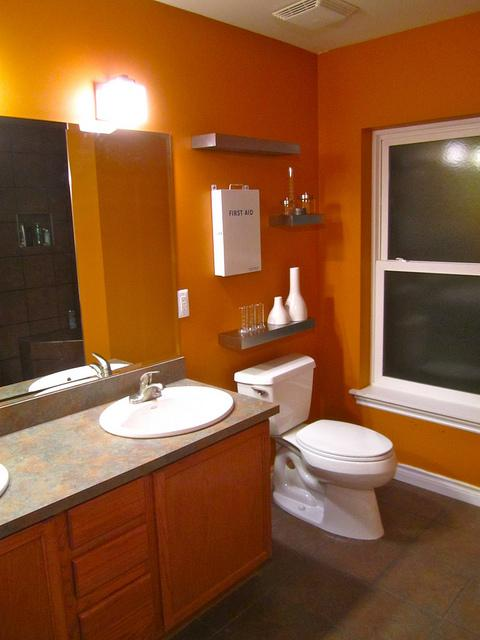What color is the writing on front of the first aid case on the wall? Please explain your reasoning. black. The writing is not blue, red, or yellow. 